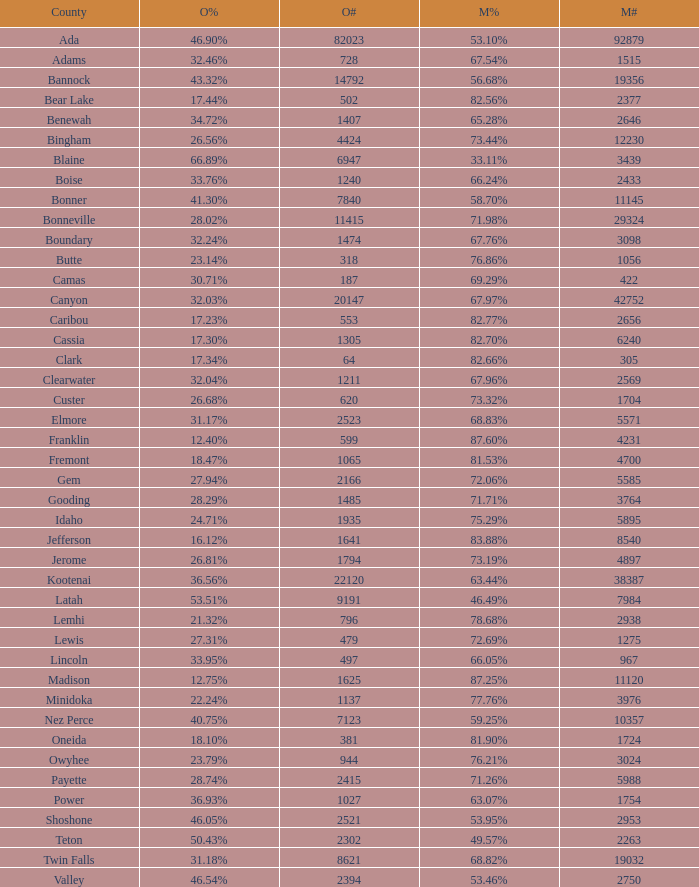What is the McCain vote percentage in Jerome county? 73.19%. 